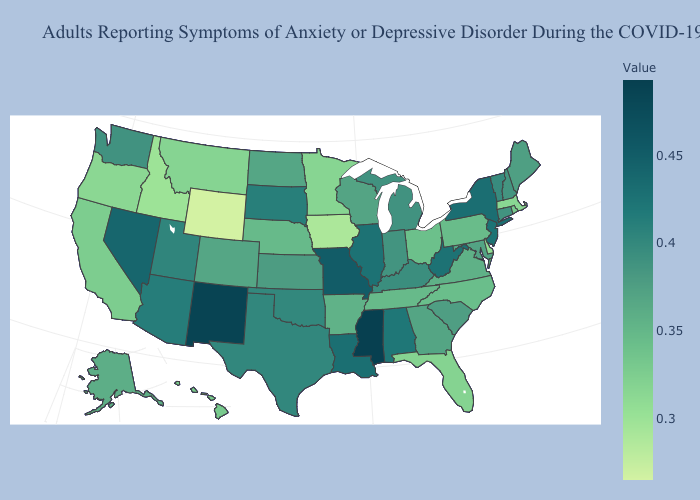Does New York have the highest value in the Northeast?
Quick response, please. Yes. Does Arkansas have the lowest value in the South?
Concise answer only. No. Does Kentucky have the lowest value in the USA?
Give a very brief answer. No. 